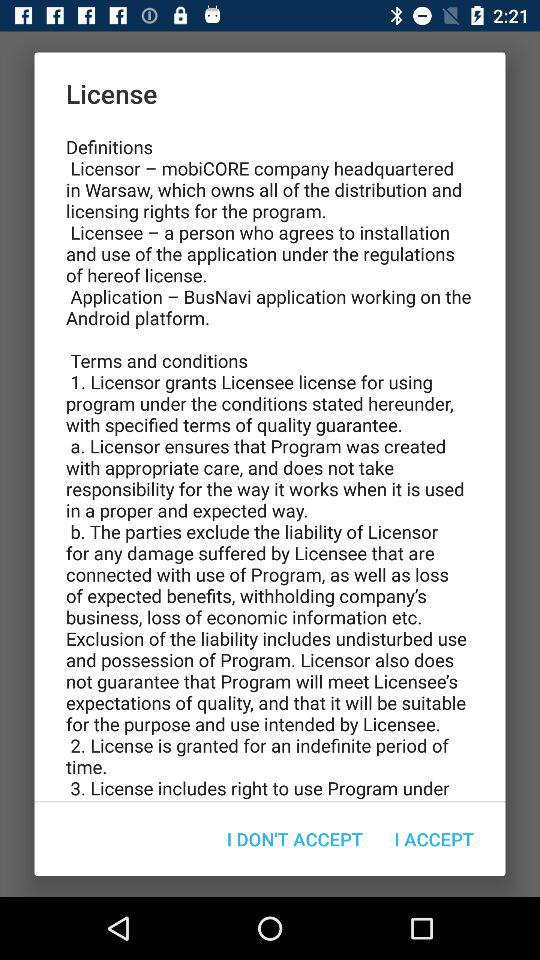Where is mobiCORE Company's headquarters? The mobiCORE company is headquartered in Warsaw. 